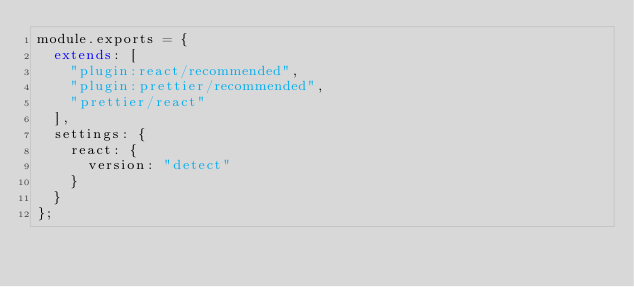<code> <loc_0><loc_0><loc_500><loc_500><_JavaScript_>module.exports = {
  extends: [
    "plugin:react/recommended",
    "plugin:prettier/recommended",
    "prettier/react"
  ],
  settings: {
    react: {
      version: "detect"
    }
  }
};
</code> 